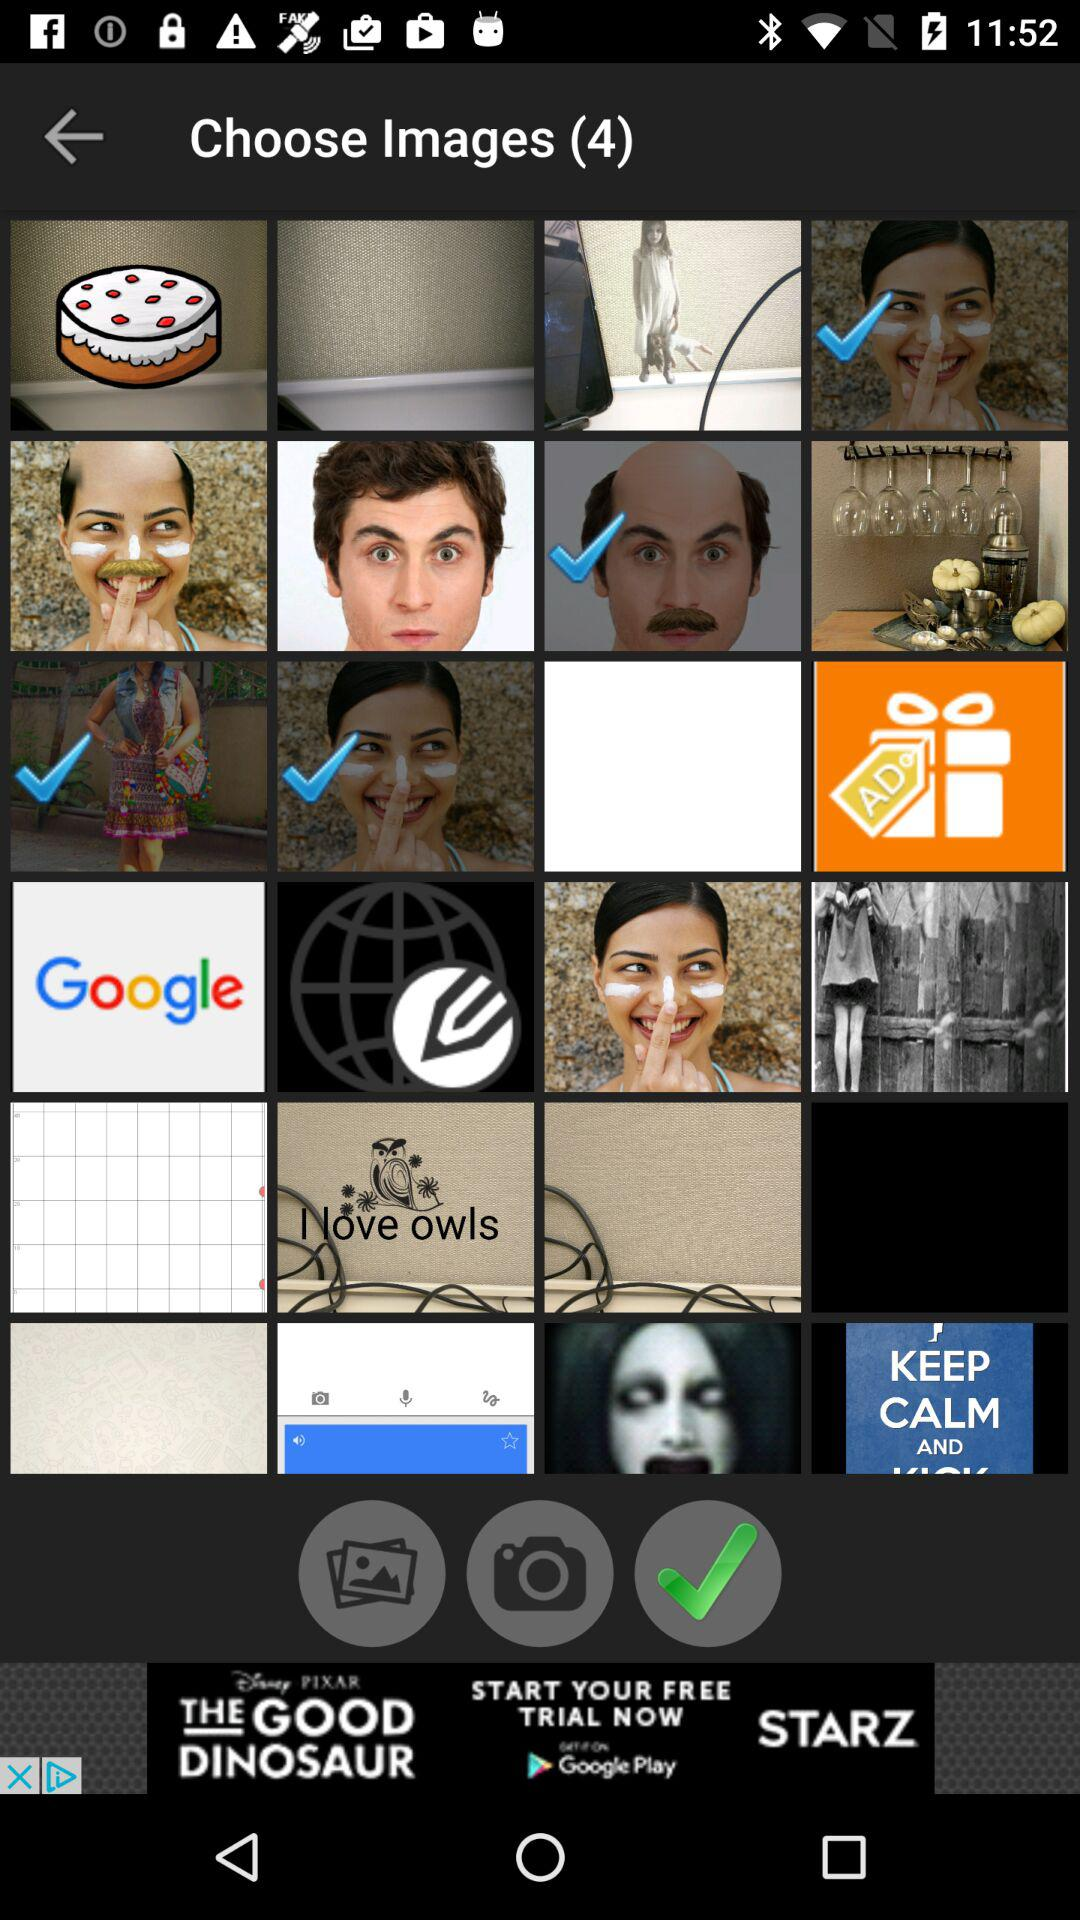What is the count of the chosen image? The count of the chosen image is 4. 